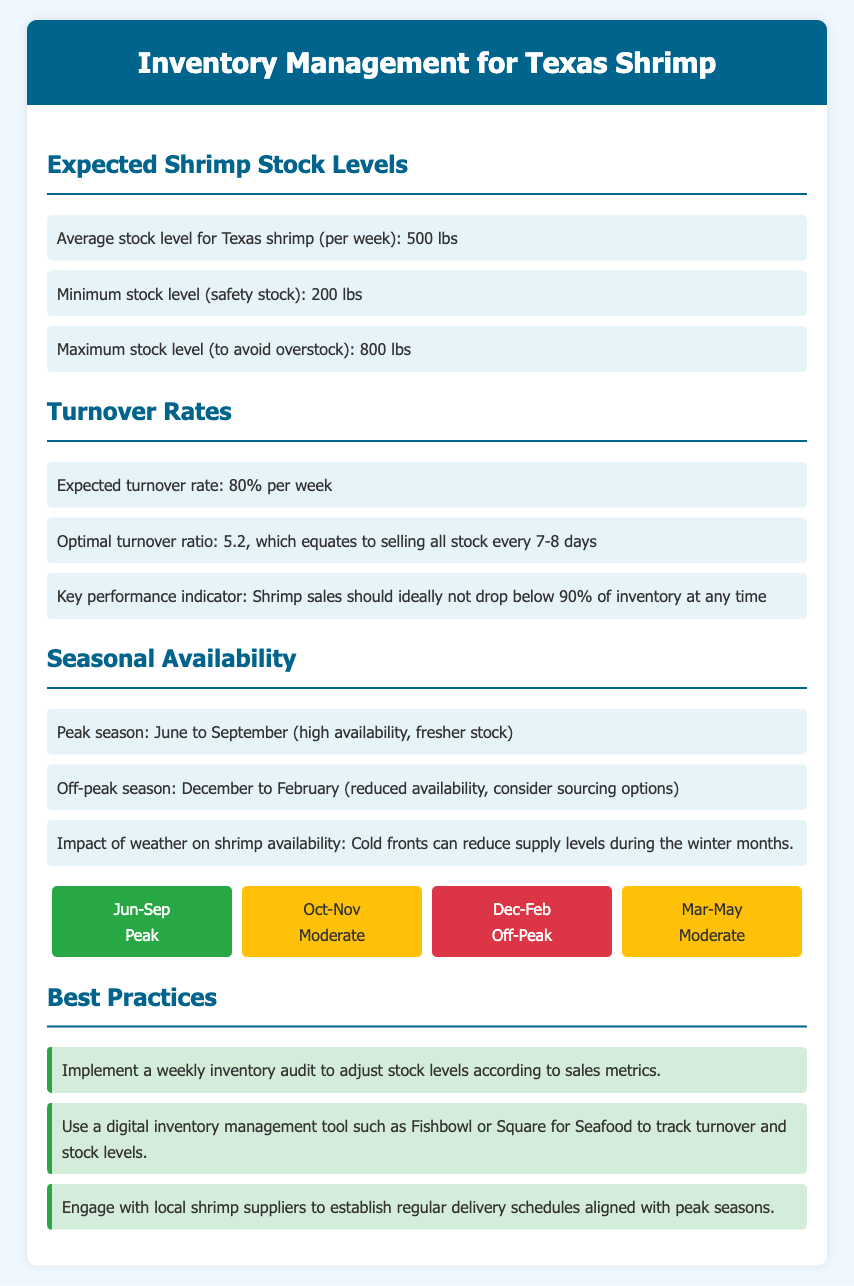What is the average stock level for Texas shrimp per week? The document states the average stock level is given as part of the expected shrimp stock levels.
Answer: 500 lbs What is the minimum stock level for Texas shrimp? The document specifies the minimum stock level as part of the expected shrimp stock levels.
Answer: 200 lbs What is the expected turnover rate for Texas shrimp? The document mentions the expected turnover rate in the turnover rates section.
Answer: 80% What months are considered peak season for Texas shrimp? The document identifies that peak season is from June to September in the seasonal availability section.
Answer: June to September What should the shrimp sales ideally not drop below? The document indicates a key performance indicator for shrimp sales in relation to inventory.
Answer: 90% What is the optimal turnover ratio? The document provides the optimal turnover ratio in the turnover rates section, which relates to selling all stock.
Answer: 5.2 What is a suggested practice for inventory management in this document? The document lists best practices related to inventory management for Texas shrimp.
Answer: Weekly inventory audit Which months are categorized as off-peak for Texas shrimp availability? The document details the months identified for reduced shrimp availability.
Answer: December to February What impact does weather have on shrimp availability according to the document? The document mentions the effect of weather on shrimp supply in the seasonal availability section.
Answer: Cold fronts can reduce supply levels 